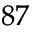Convert formula to latex. <formula><loc_0><loc_0><loc_500><loc_500>^ { 8 7 }</formula> 